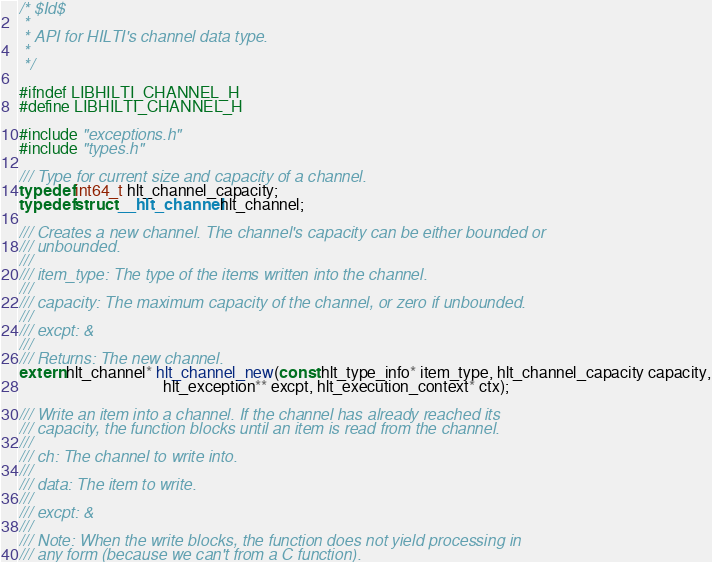<code> <loc_0><loc_0><loc_500><loc_500><_C_>/* $Id$
 *
 * API for HILTI's channel data type.
 *
 */

#ifndef LIBHILTI_CHANNEL_H
#define LIBHILTI_CHANNEL_H

#include "exceptions.h"
#include "types.h"

/// Type for current size and capacity of a channel.
typedef int64_t hlt_channel_capacity;
typedef struct __hlt_channel hlt_channel;

/// Creates a new channel. The channel's capacity can be either bounded or
/// unbounded.
///
/// item_type: The type of the items written into the channel.
///
/// capacity: The maximum capacity of the channel, or zero if unbounded.
///
/// excpt: &
///
/// Returns: The new channel.
extern hlt_channel* hlt_channel_new(const hlt_type_info* item_type, hlt_channel_capacity capacity,
                                    hlt_exception** excpt, hlt_execution_context* ctx);

/// Write an item into a channel. If the channel has already reached its
/// capacity, the function blocks until an item is read from the channel.
///
/// ch: The channel to write into.
///
/// data: The item to write.
///
/// excpt: &
///
/// Note: When the write blocks, the function does not yield processing in
/// any form (because we can't from a C function).</code> 